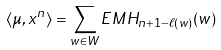<formula> <loc_0><loc_0><loc_500><loc_500>\langle \mu , x ^ { n } \rangle = \sum _ { w \in W } E M H _ { n + 1 - \ell ( w ) } ( w )</formula> 